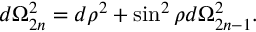Convert formula to latex. <formula><loc_0><loc_0><loc_500><loc_500>d \Omega _ { 2 n } ^ { 2 } = d \rho ^ { 2 } + \sin ^ { 2 } \rho d \Omega _ { 2 n - 1 } ^ { 2 } .</formula> 